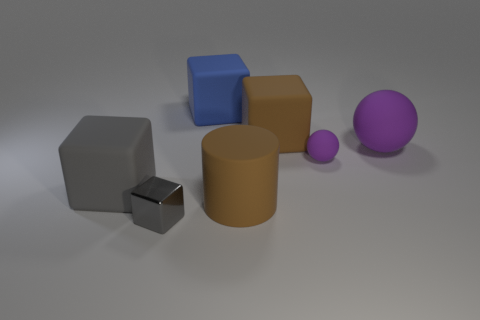Can you tell me the material that the big cylinder seems to be made of? The large cylinder has a matte finish and appears to be made of a non-reflective material, possibly suggesting that it is made of rubber or a similar material. 